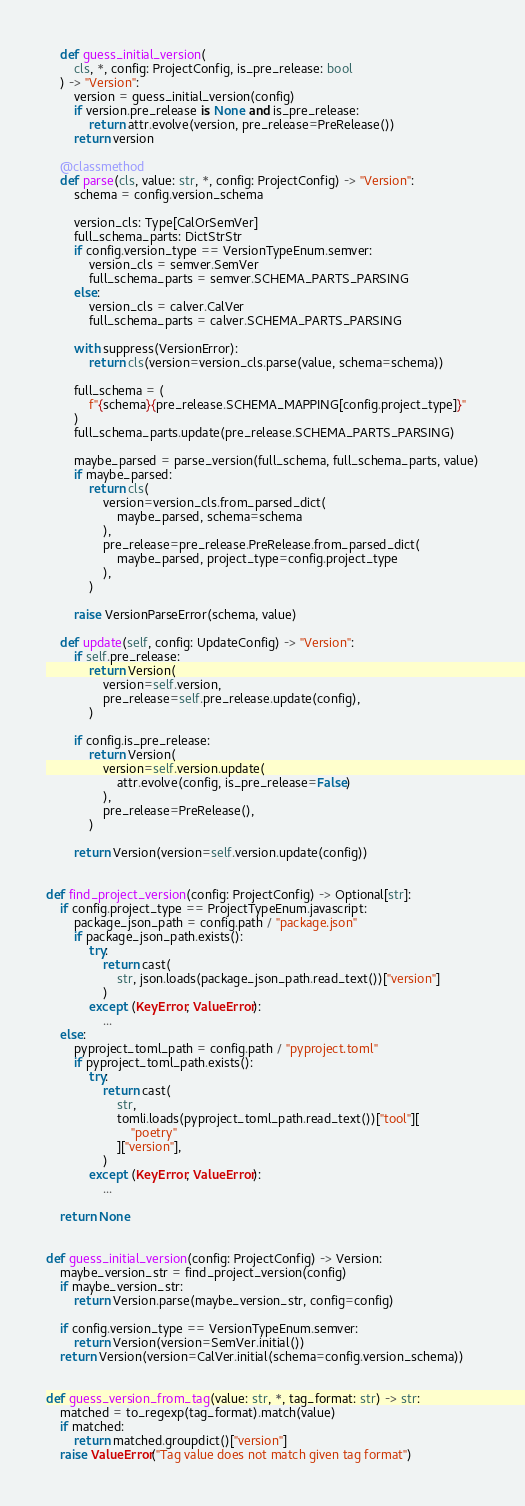Convert code to text. <code><loc_0><loc_0><loc_500><loc_500><_Python_>    def guess_initial_version(
        cls, *, config: ProjectConfig, is_pre_release: bool
    ) -> "Version":
        version = guess_initial_version(config)
        if version.pre_release is None and is_pre_release:
            return attr.evolve(version, pre_release=PreRelease())
        return version

    @classmethod
    def parse(cls, value: str, *, config: ProjectConfig) -> "Version":
        schema = config.version_schema

        version_cls: Type[CalOrSemVer]
        full_schema_parts: DictStrStr
        if config.version_type == VersionTypeEnum.semver:
            version_cls = semver.SemVer
            full_schema_parts = semver.SCHEMA_PARTS_PARSING
        else:
            version_cls = calver.CalVer
            full_schema_parts = calver.SCHEMA_PARTS_PARSING

        with suppress(VersionError):
            return cls(version=version_cls.parse(value, schema=schema))

        full_schema = (
            f"{schema}{pre_release.SCHEMA_MAPPING[config.project_type]}"
        )
        full_schema_parts.update(pre_release.SCHEMA_PARTS_PARSING)

        maybe_parsed = parse_version(full_schema, full_schema_parts, value)
        if maybe_parsed:
            return cls(
                version=version_cls.from_parsed_dict(
                    maybe_parsed, schema=schema
                ),
                pre_release=pre_release.PreRelease.from_parsed_dict(
                    maybe_parsed, project_type=config.project_type
                ),
            )

        raise VersionParseError(schema, value)

    def update(self, config: UpdateConfig) -> "Version":
        if self.pre_release:
            return Version(
                version=self.version,
                pre_release=self.pre_release.update(config),
            )

        if config.is_pre_release:
            return Version(
                version=self.version.update(
                    attr.evolve(config, is_pre_release=False)
                ),
                pre_release=PreRelease(),
            )

        return Version(version=self.version.update(config))


def find_project_version(config: ProjectConfig) -> Optional[str]:
    if config.project_type == ProjectTypeEnum.javascript:
        package_json_path = config.path / "package.json"
        if package_json_path.exists():
            try:
                return cast(
                    str, json.loads(package_json_path.read_text())["version"]
                )
            except (KeyError, ValueError):
                ...
    else:
        pyproject_toml_path = config.path / "pyproject.toml"
        if pyproject_toml_path.exists():
            try:
                return cast(
                    str,
                    tomli.loads(pyproject_toml_path.read_text())["tool"][
                        "poetry"
                    ]["version"],
                )
            except (KeyError, ValueError):
                ...

    return None


def guess_initial_version(config: ProjectConfig) -> Version:
    maybe_version_str = find_project_version(config)
    if maybe_version_str:
        return Version.parse(maybe_version_str, config=config)

    if config.version_type == VersionTypeEnum.semver:
        return Version(version=SemVer.initial())
    return Version(version=CalVer.initial(schema=config.version_schema))


def guess_version_from_tag(value: str, *, tag_format: str) -> str:
    matched = to_regexp(tag_format).match(value)
    if matched:
        return matched.groupdict()["version"]
    raise ValueError("Tag value does not match given tag format")
</code> 